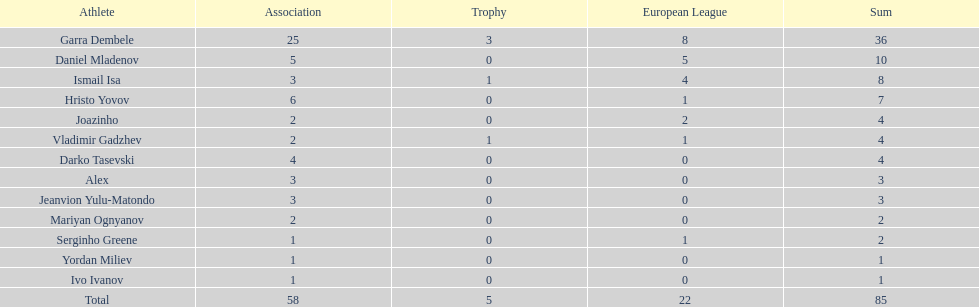Which is the only player from germany? Jeanvion Yulu-Matondo. 